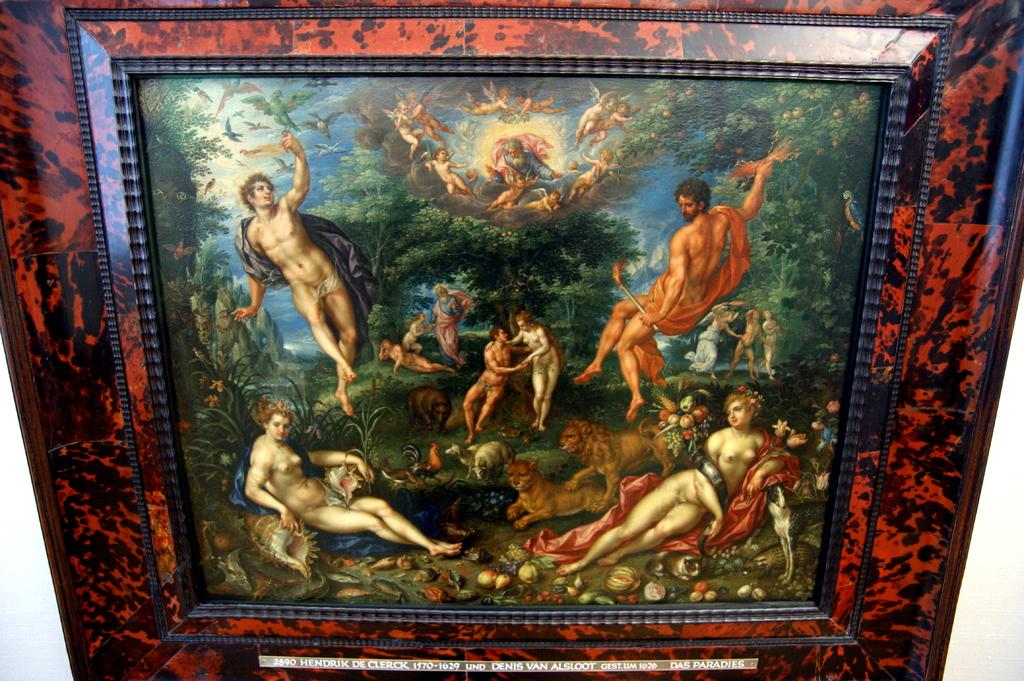Is there an artist on this painting?
Make the answer very short. Yes. 